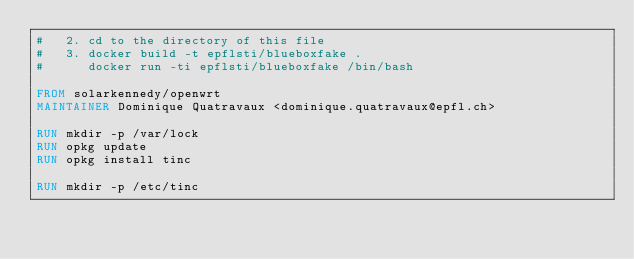<code> <loc_0><loc_0><loc_500><loc_500><_Dockerfile_>#   2. cd to the directory of this file
#   3. docker build -t epflsti/blueboxfake .
#      docker run -ti epflsti/blueboxfake /bin/bash

FROM solarkennedy/openwrt
MAINTAINER Dominique Quatravaux <dominique.quatravaux@epfl.ch>

RUN mkdir -p /var/lock
RUN opkg update
RUN opkg install tinc

RUN mkdir -p /etc/tinc
</code> 